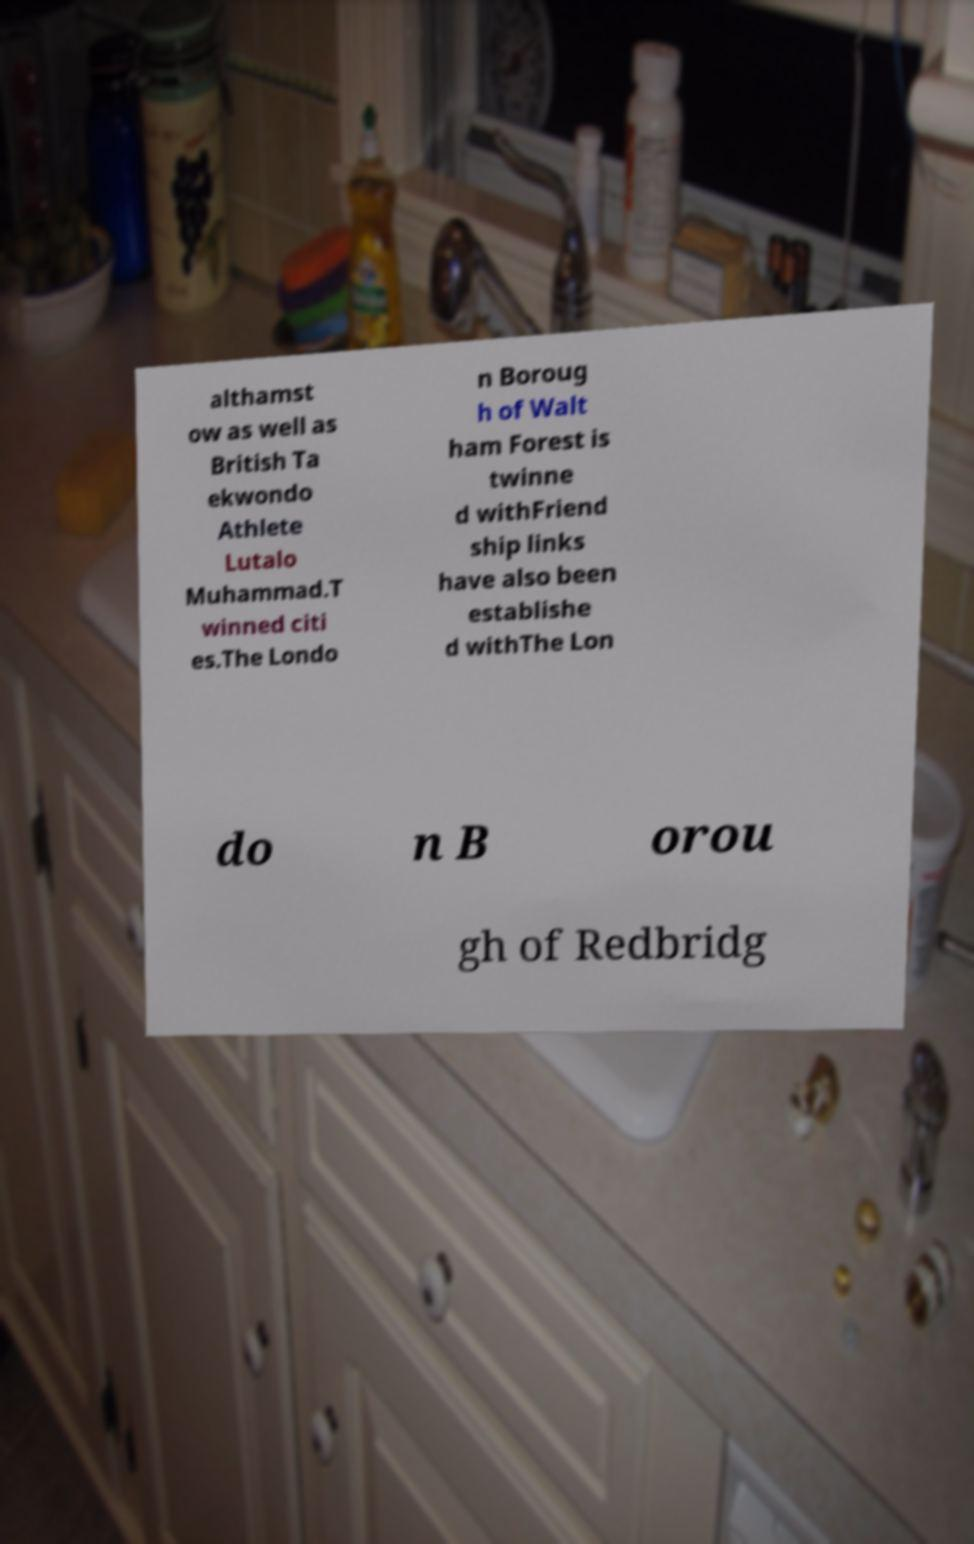I need the written content from this picture converted into text. Can you do that? althamst ow as well as British Ta ekwondo Athlete Lutalo Muhammad.T winned citi es.The Londo n Boroug h of Walt ham Forest is twinne d withFriend ship links have also been establishe d withThe Lon do n B orou gh of Redbridg 